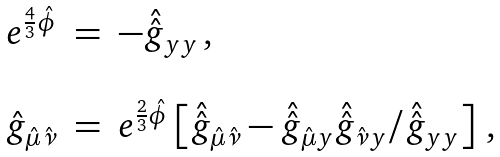<formula> <loc_0><loc_0><loc_500><loc_500>\begin{array} { r c l } e ^ { \frac { 4 } { 3 } \hat { \phi } } & = & - \hat { \hat { g } } _ { y y } \, , \\ & & \\ \hat { g } _ { \hat { \mu } \hat { \nu } } & = & e ^ { \frac { 2 } { 3 } \hat { \phi } } \left [ \hat { \hat { g } } _ { \hat { \mu } \hat { \nu } } - \hat { \hat { g } } _ { \hat { \mu } y } \hat { \hat { g } } _ { \hat { \nu } y } / \hat { \hat { g } } _ { y y } \right ] \, , \end{array}</formula> 